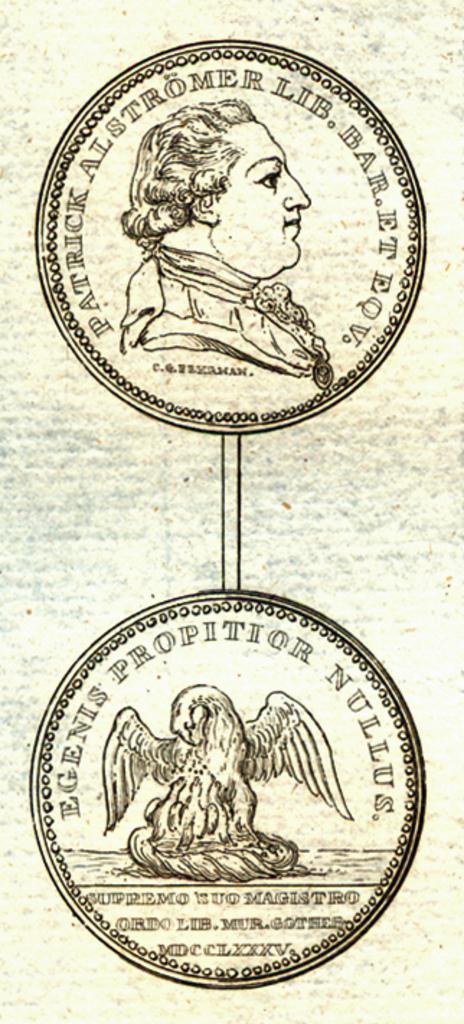Can you describe this image briefly? In this picture there is a logo where there is a face of a person which has something written around it and in the below picture there is an object which has something written above and below it. 